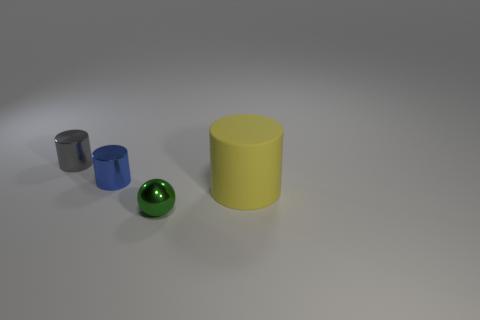Add 1 yellow objects. How many objects exist? 5 Subtract all cylinders. How many objects are left? 1 Add 2 big yellow things. How many big yellow things are left? 3 Add 2 gray rubber blocks. How many gray rubber blocks exist? 2 Subtract 0 purple spheres. How many objects are left? 4 Subtract all small brown metal cubes. Subtract all tiny green objects. How many objects are left? 3 